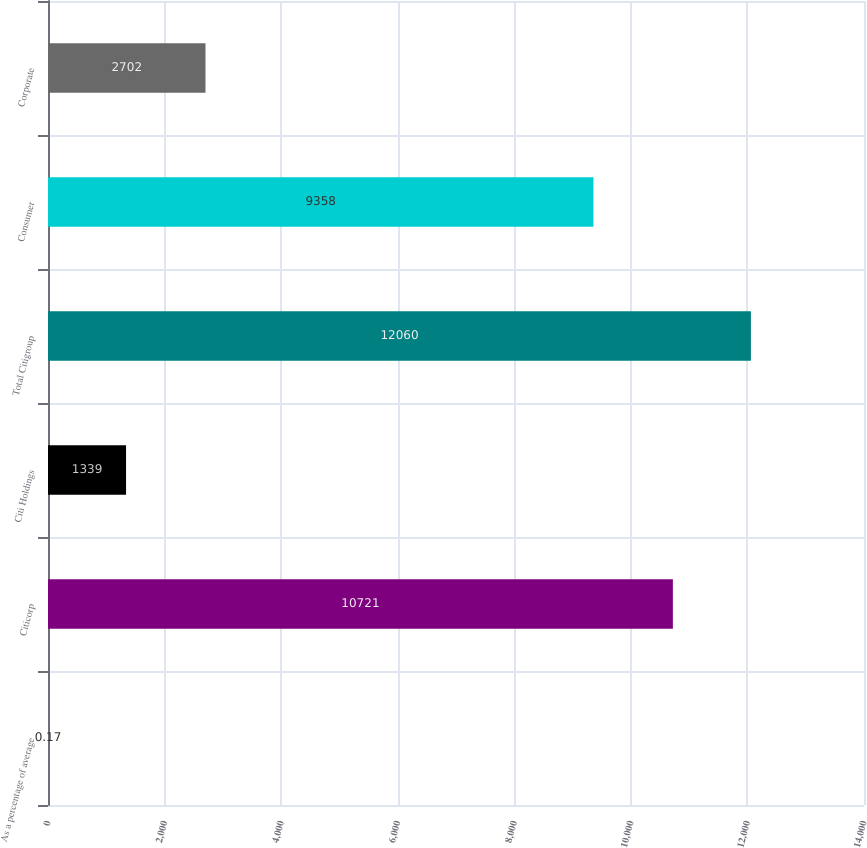Convert chart. <chart><loc_0><loc_0><loc_500><loc_500><bar_chart><fcel>As a percentage of average<fcel>Citicorp<fcel>Citi Holdings<fcel>Total Citigroup<fcel>Consumer<fcel>Corporate<nl><fcel>0.17<fcel>10721<fcel>1339<fcel>12060<fcel>9358<fcel>2702<nl></chart> 